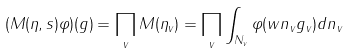<formula> <loc_0><loc_0><loc_500><loc_500>( M ( \eta , s ) \varphi ) ( g ) = \prod _ { v } M ( \eta _ { v } ) = \prod _ { v } \int _ { N _ { v } } \varphi ( w n _ { v } g _ { v } ) d n _ { v }</formula> 